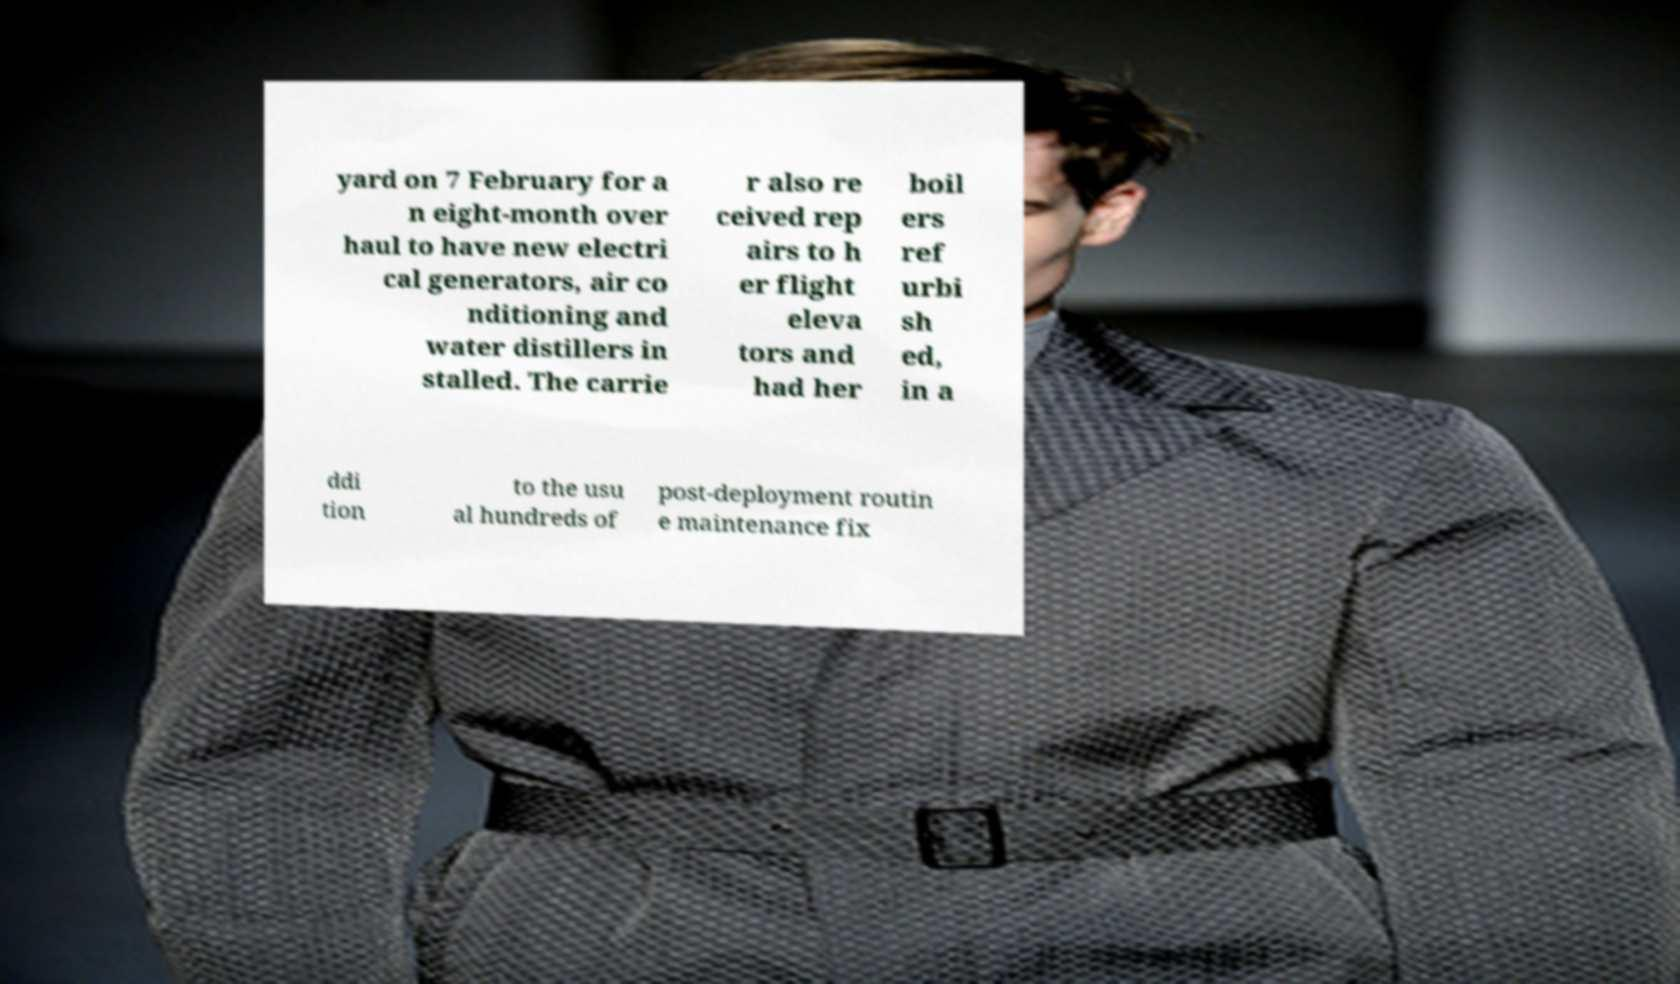Please identify and transcribe the text found in this image. yard on 7 February for a n eight-month over haul to have new electri cal generators, air co nditioning and water distillers in stalled. The carrie r also re ceived rep airs to h er flight eleva tors and had her boil ers ref urbi sh ed, in a ddi tion to the usu al hundreds of post-deployment routin e maintenance fix 